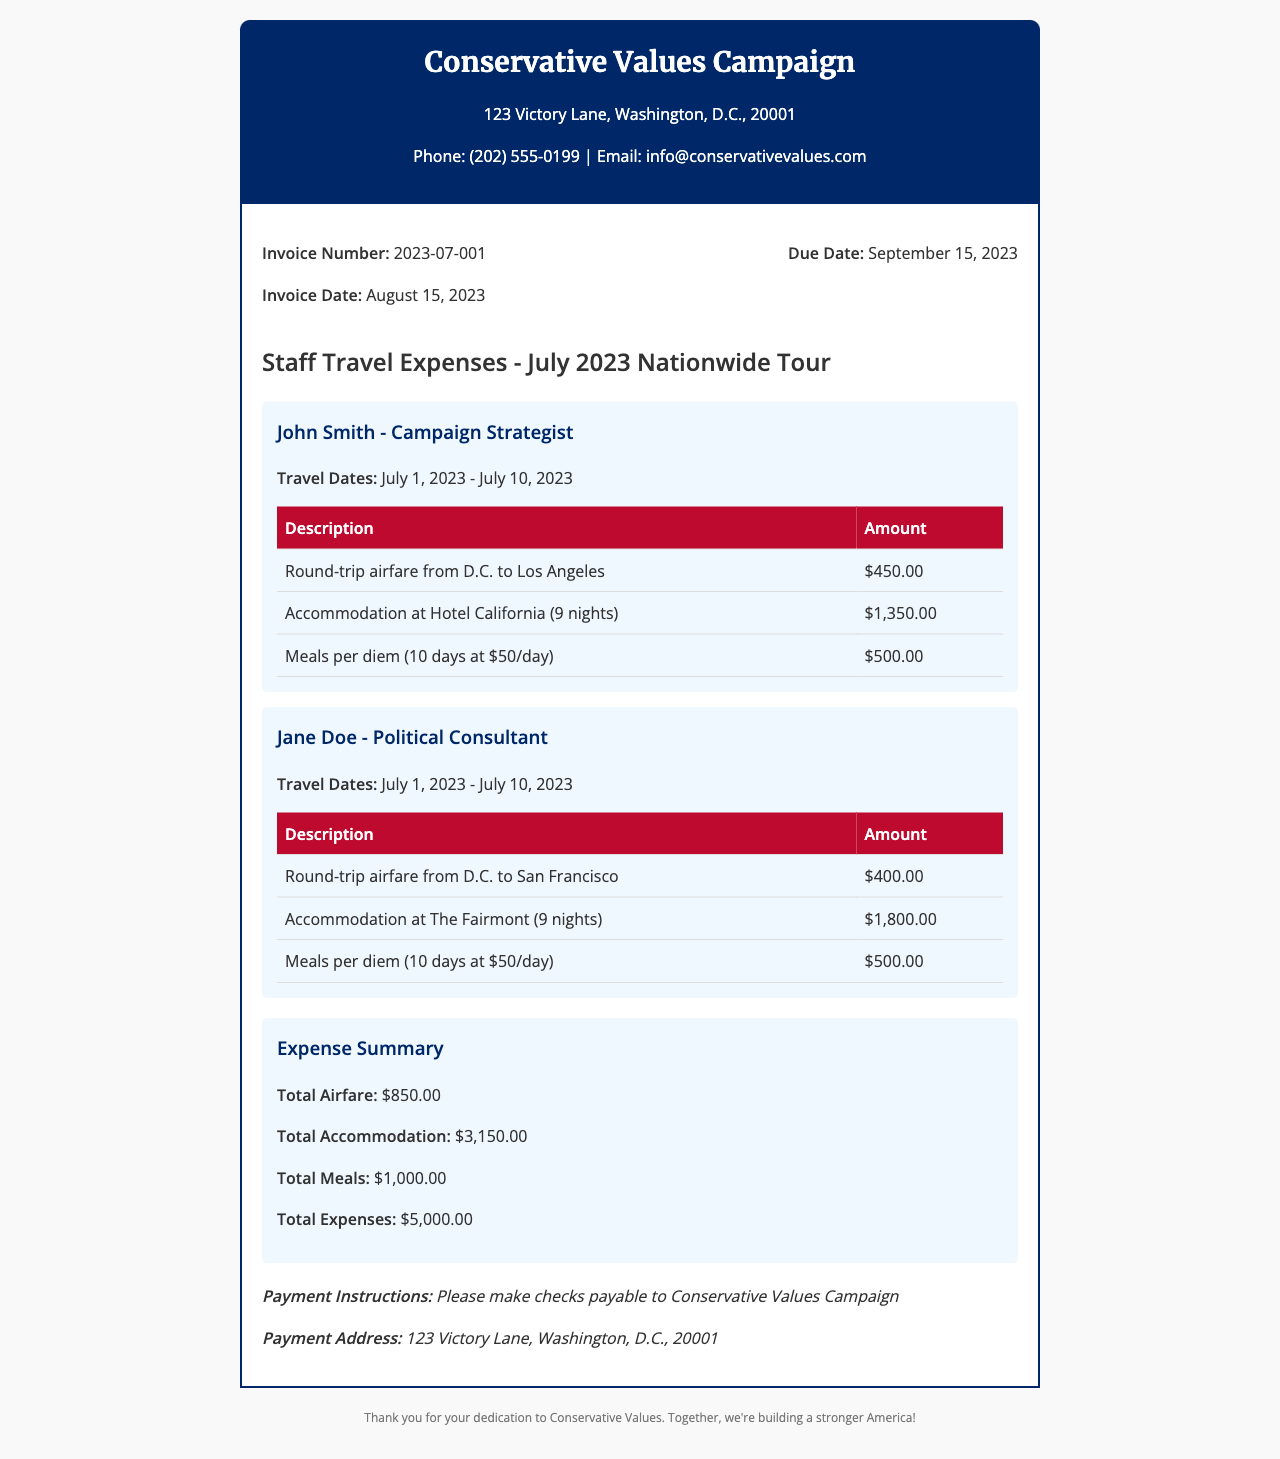What is the invoice number? The invoice number is listed at the top of the document, which is 2023-07-001.
Answer: 2023-07-001 What is the total amount for accommodation? The total accommodation cost is calculated by summing the individual accommodation costs listed for each staff member, which is $1,350.00 + $1,800.00.
Answer: $3,150.00 Who is the campaign strategist? The document lists John Smith as the campaign strategist in the section for staff travel expenses.
Answer: John Smith What are the travel dates for Jane Doe? The travel dates for Jane Doe are specified in her section as July 1, 2023 - July 10, 2023.
Answer: July 1, 2023 - July 10, 2023 What is the total amount for meals? The total meals cost can be found by summing up the meals per diem for both staff members, which is $500.00 + $500.00.
Answer: $1,000.00 What is the due date for the invoice? The due date for the invoice is stated in the invoice details section as September 15, 2023.
Answer: September 15, 2023 How many nights did John Smith stay at the hotel? John Smith stayed for 9 nights at Hotel California as noted in his expenses.
Answer: 9 nights What is the payment address for the campaign? The payment address is listed at the bottom of the document as 123 Victory Lane, Washington, D.C., 20001.
Answer: 123 Victory Lane, Washington, D.C., 20001 What is the total amount of expenses for the tour? The total expenses are summarized in the document and equal $5,000.00.
Answer: $5,000.00 